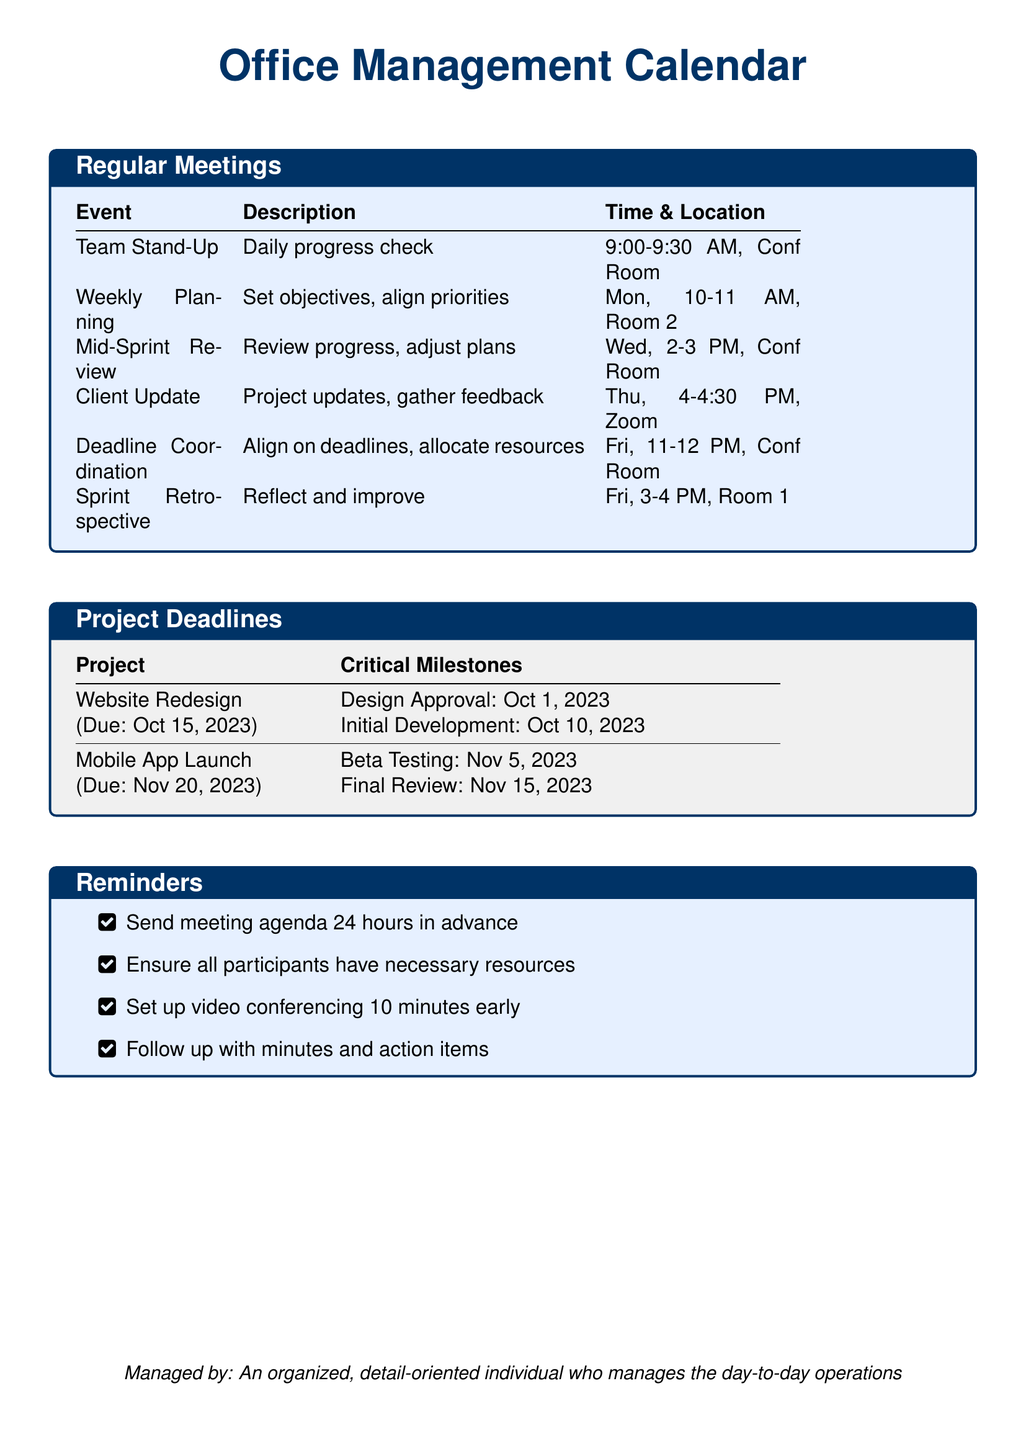What time does the Team Stand-Up start? The Team Stand-Up starts at 9:00 AM as listed in the Regular Meetings section.
Answer: 9:00 AM When is the Deadline Coordination meeting scheduled? The Deadline Coordination meeting is scheduled for Friday at 11 AM, as per the Regular Meetings section.
Answer: Friday, 11 AM What is the due date for the Website Redesign project? The due date for the Website Redesign project is stated as October 15, 2023 in the Project Deadlines section.
Answer: October 15, 2023 Which meeting is held on Wednesdays? The meeting held on Wednesdays is the Mid-Sprint Review, based on the Regular Meetings schedule.
Answer: Mid-Sprint Review How many critical milestones are listed for the Mobile App Launch project? The Mobile App Launch project has two critical milestones listed in the Project Deadlines section.
Answer: Two What reminder is associated with sending meeting agendas? The reminder specifies to send the meeting agenda 24 hours in advance.
Answer: Send meeting agenda 24 hours in advance Which day is dedicated to the Sprint Retrospective? The Sprint Retrospective is scheduled for Friday, according to the Regular Meetings table.
Answer: Friday What is the location for the Weekly Planning meeting? The Weekly Planning meeting takes place in Room 2, as detailed in the Regular Meetings section.
Answer: Room 2 